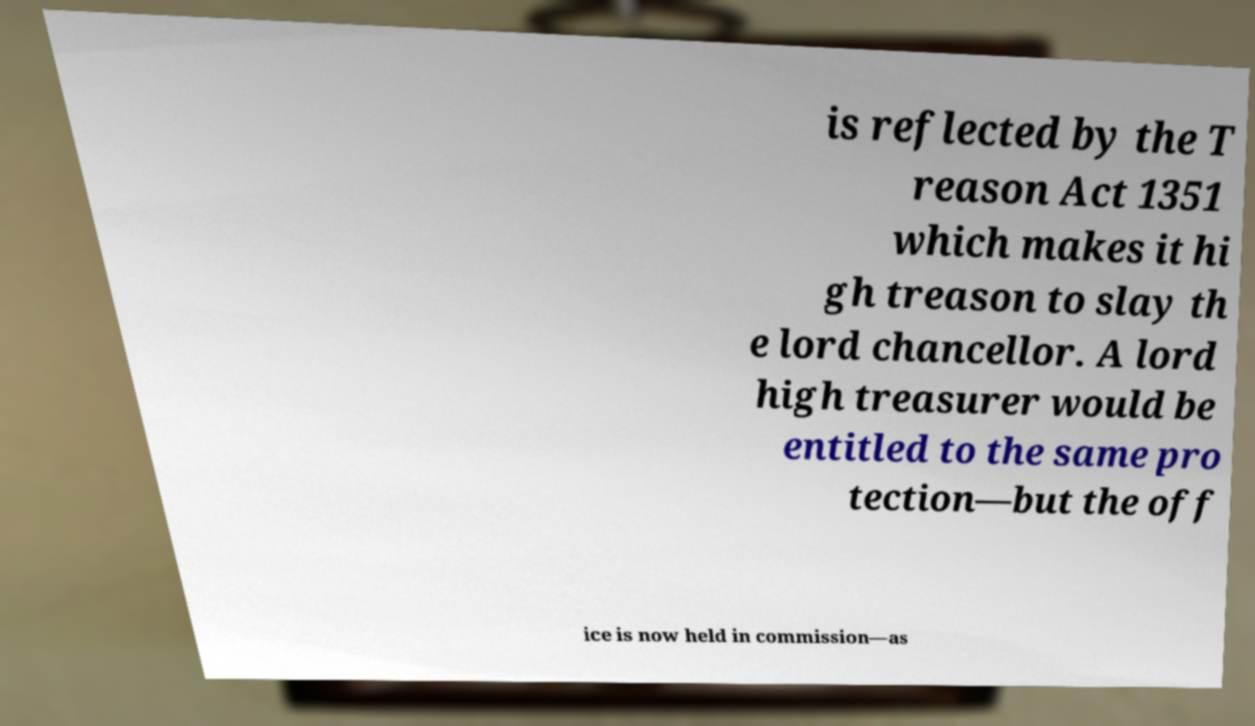Can you accurately transcribe the text from the provided image for me? is reflected by the T reason Act 1351 which makes it hi gh treason to slay th e lord chancellor. A lord high treasurer would be entitled to the same pro tection—but the off ice is now held in commission—as 